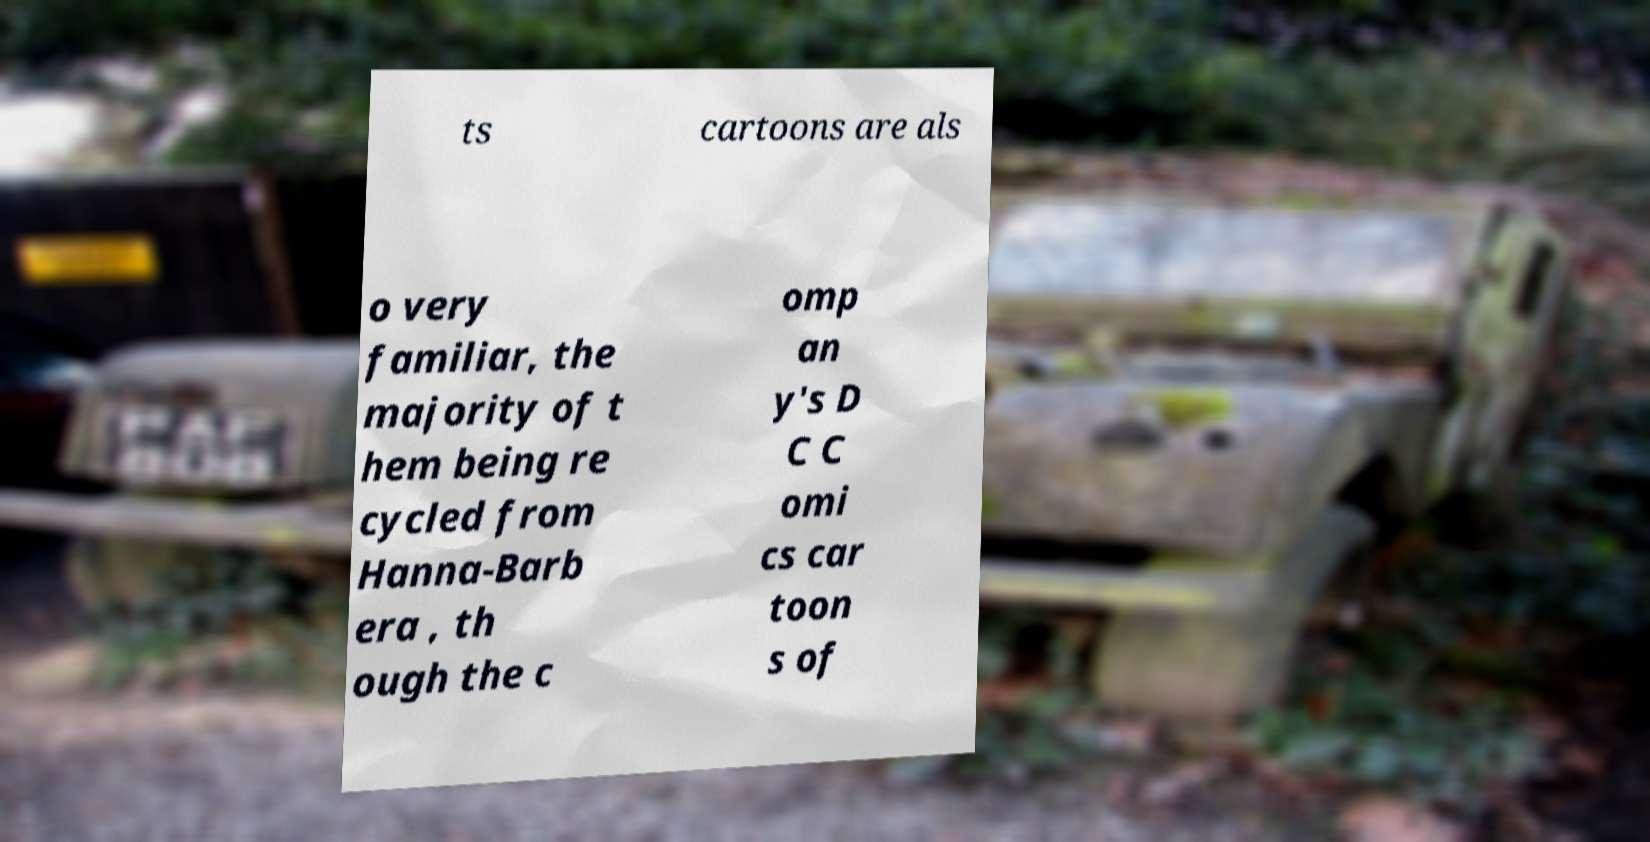Could you extract and type out the text from this image? ts cartoons are als o very familiar, the majority of t hem being re cycled from Hanna-Barb era , th ough the c omp an y's D C C omi cs car toon s of 